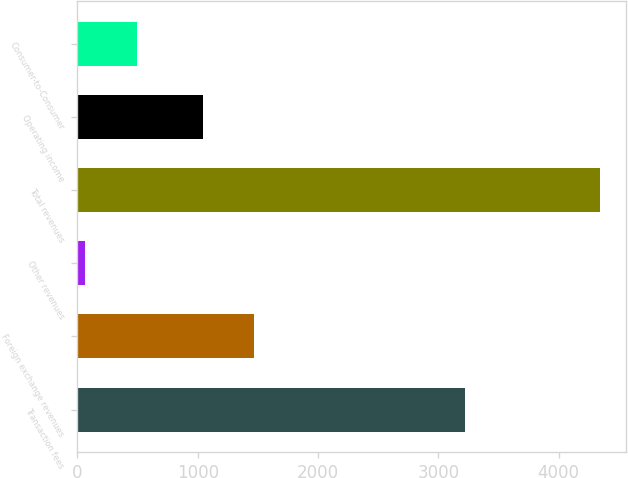<chart> <loc_0><loc_0><loc_500><loc_500><bar_chart><fcel>Transaction fees<fcel>Foreign exchange revenues<fcel>Other revenues<fcel>Total revenues<fcel>Operating income<fcel>Consumer-to-Consumer<nl><fcel>3221<fcel>1469.81<fcel>65.8<fcel>4343.9<fcel>1042<fcel>493.61<nl></chart> 